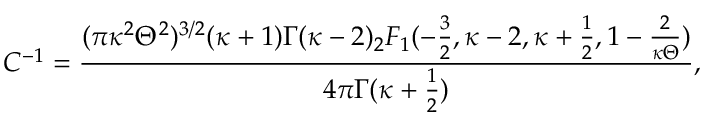Convert formula to latex. <formula><loc_0><loc_0><loc_500><loc_500>C ^ { - 1 } = \frac { ( \pi \kappa ^ { 2 } \Theta ^ { 2 } ) ^ { 3 / 2 } ( \kappa + 1 ) \Gamma ( \kappa - 2 ) _ { 2 } F _ { 1 } ( - \frac { 3 } { 2 } , \kappa - 2 , \kappa + \frac { 1 } { 2 } , 1 - \frac { 2 } { \kappa \Theta } ) } { 4 \pi \Gamma ( \kappa + \frac { 1 } { 2 } ) } ,</formula> 